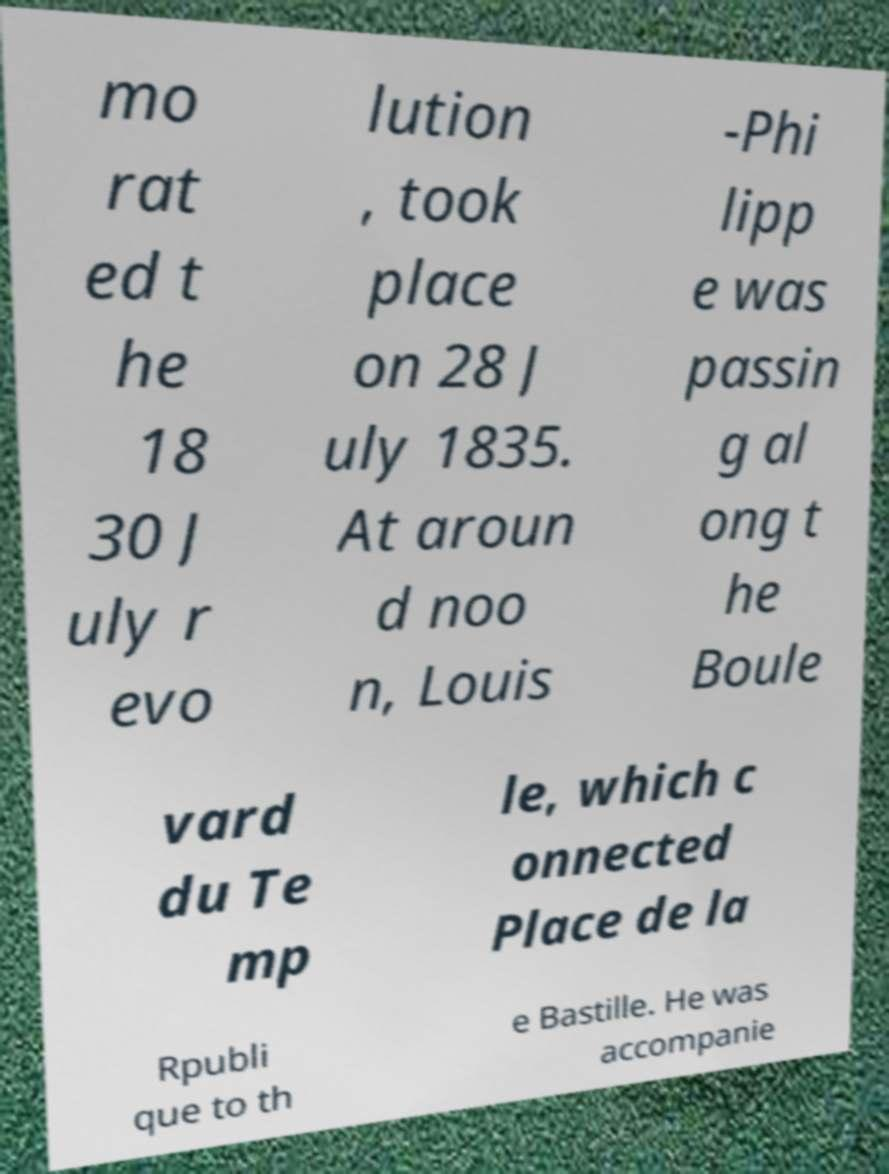There's text embedded in this image that I need extracted. Can you transcribe it verbatim? mo rat ed t he 18 30 J uly r evo lution , took place on 28 J uly 1835. At aroun d noo n, Louis -Phi lipp e was passin g al ong t he Boule vard du Te mp le, which c onnected Place de la Rpubli que to th e Bastille. He was accompanie 